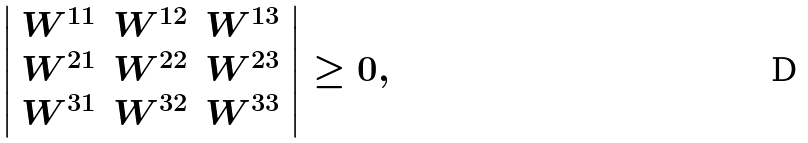<formula> <loc_0><loc_0><loc_500><loc_500>\left | \begin{array} { c c c } { { W ^ { 1 1 } } } & { { W ^ { 1 2 } } } & { { W ^ { 1 3 } } } \\ { { W ^ { 2 1 } } } & { { W ^ { 2 2 } } } & { { W ^ { 2 3 } } } \\ { { W ^ { 3 1 } } } & { { W ^ { 3 2 } } } & { { W ^ { 3 3 } } } \end{array} \right | \geq 0 ,</formula> 